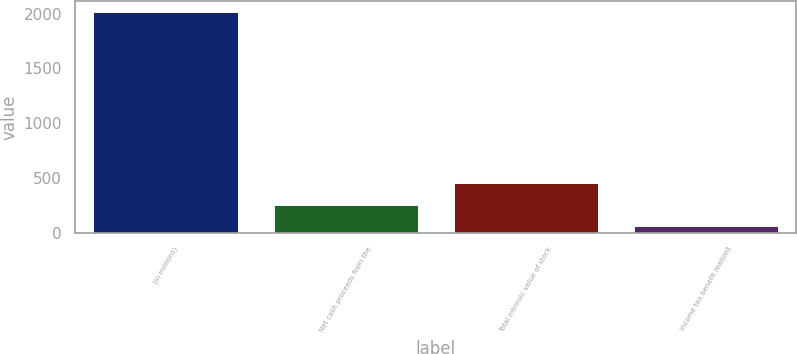Convert chart. <chart><loc_0><loc_0><loc_500><loc_500><bar_chart><fcel>(in millions)<fcel>Net cash proceeds from the<fcel>Total intrinsic value of stock<fcel>Income tax benefit realized<nl><fcel>2017<fcel>259.3<fcel>454.6<fcel>64<nl></chart> 